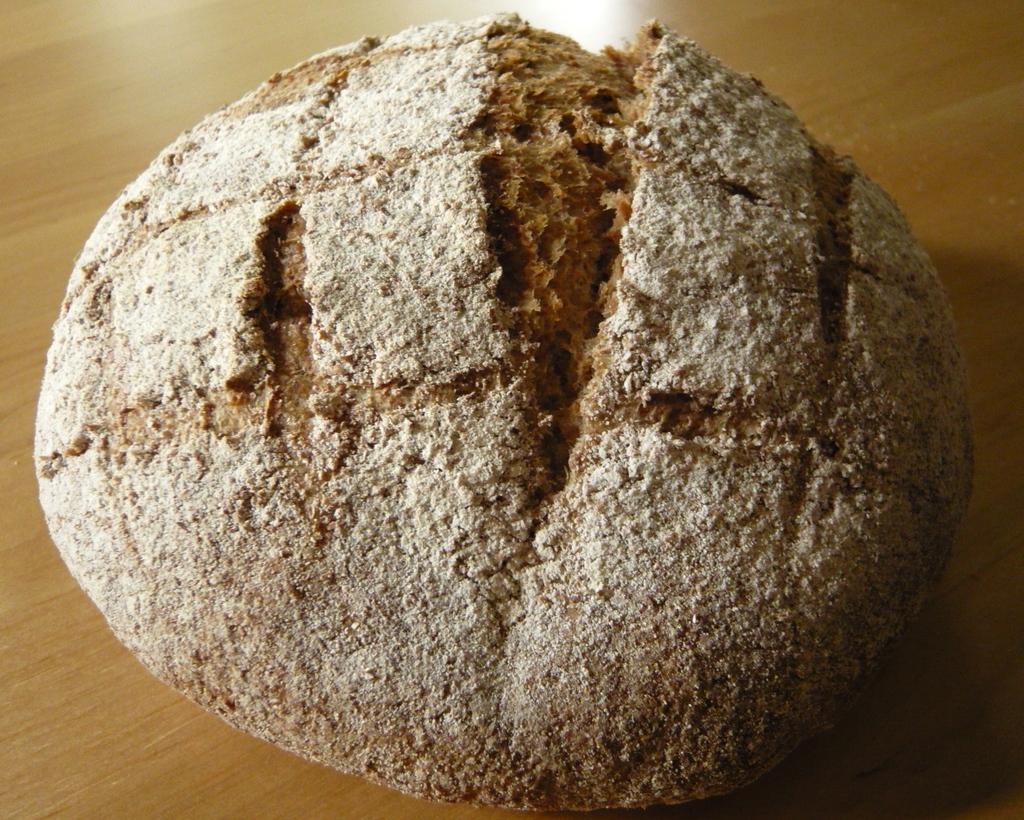In one or two sentences, can you explain what this image depicts? In the image there is a dough kept on a wooden surface. 